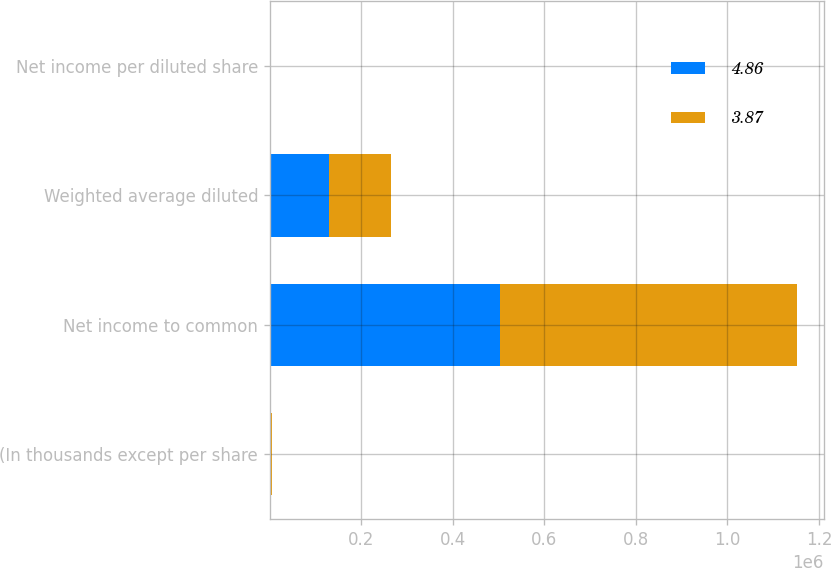Convert chart to OTSL. <chart><loc_0><loc_0><loc_500><loc_500><stacked_bar_chart><ecel><fcel>(In thousands except per share<fcel>Net income to common<fcel>Weighted average diluted<fcel>Net income per diluted share<nl><fcel>4.86<fcel>2015<fcel>503694<fcel>130189<fcel>3.87<nl><fcel>3.87<fcel>2014<fcel>648884<fcel>133652<fcel>4.86<nl></chart> 